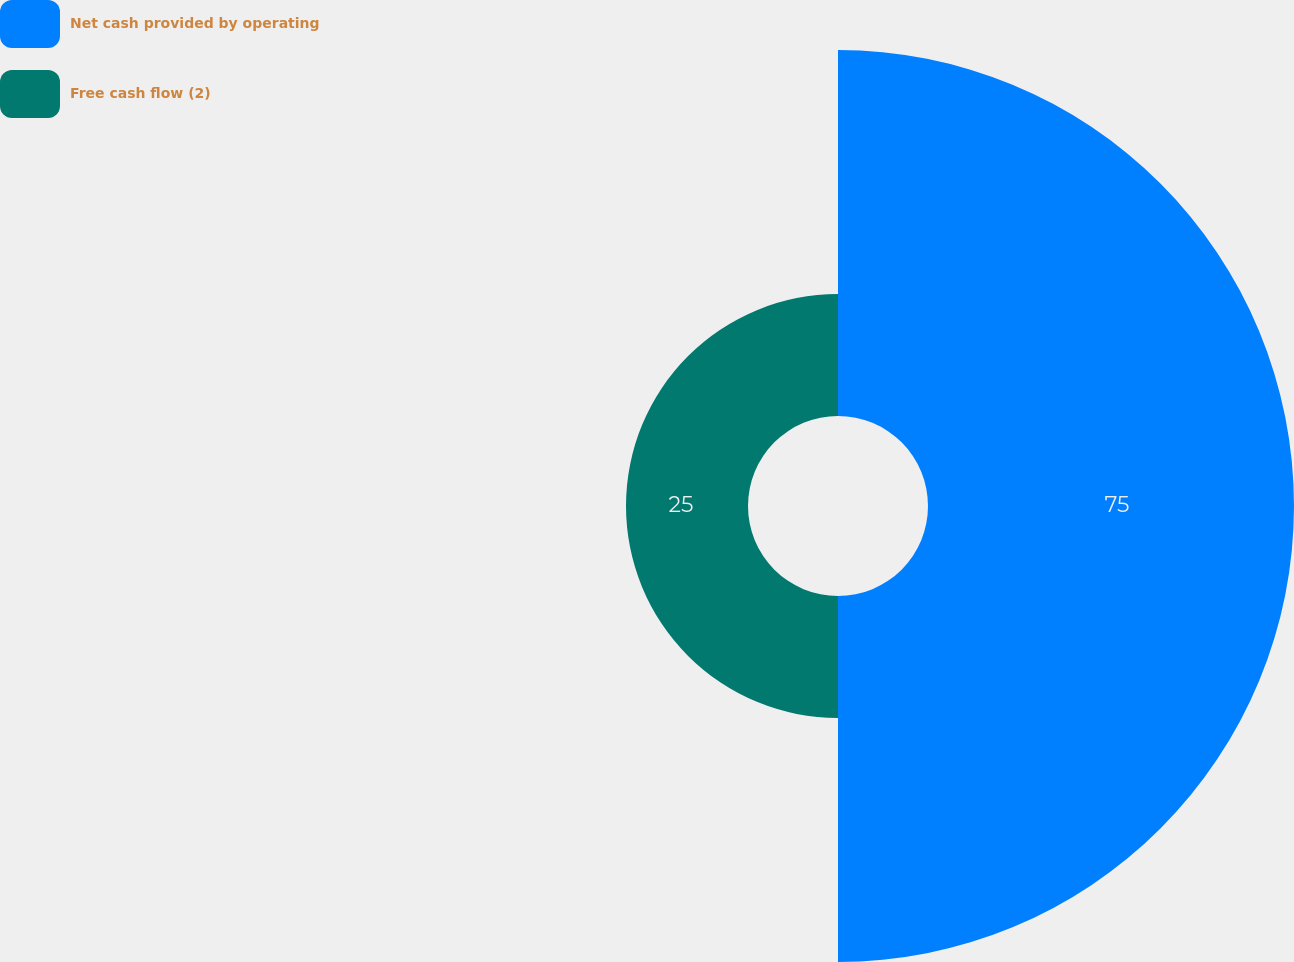Convert chart to OTSL. <chart><loc_0><loc_0><loc_500><loc_500><pie_chart><fcel>Net cash provided by operating<fcel>Free cash flow (2)<nl><fcel>75.0%<fcel>25.0%<nl></chart> 